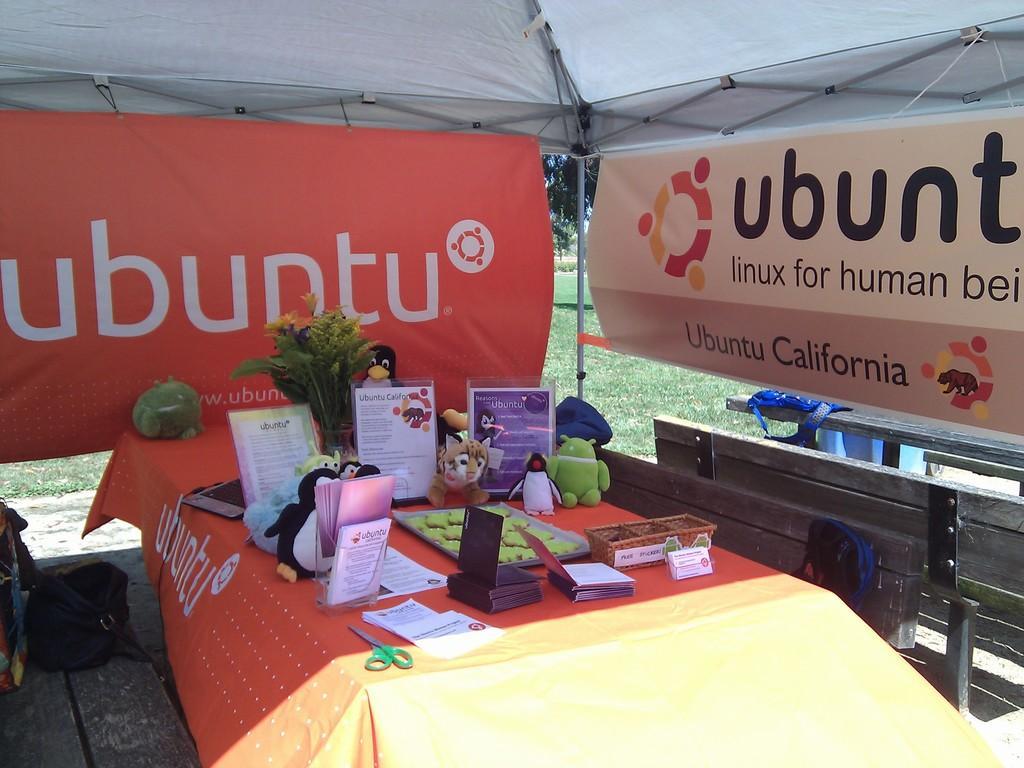Describe this image in one or two sentences. In the center of the image there is a table with some objects on it. In the background of the image there is a banner with some text. To the left side of the image there is a banner with some text. At the top of the image there is a white colored cloth. In the background of the image there is grass. To the right side of the image there are benches. 